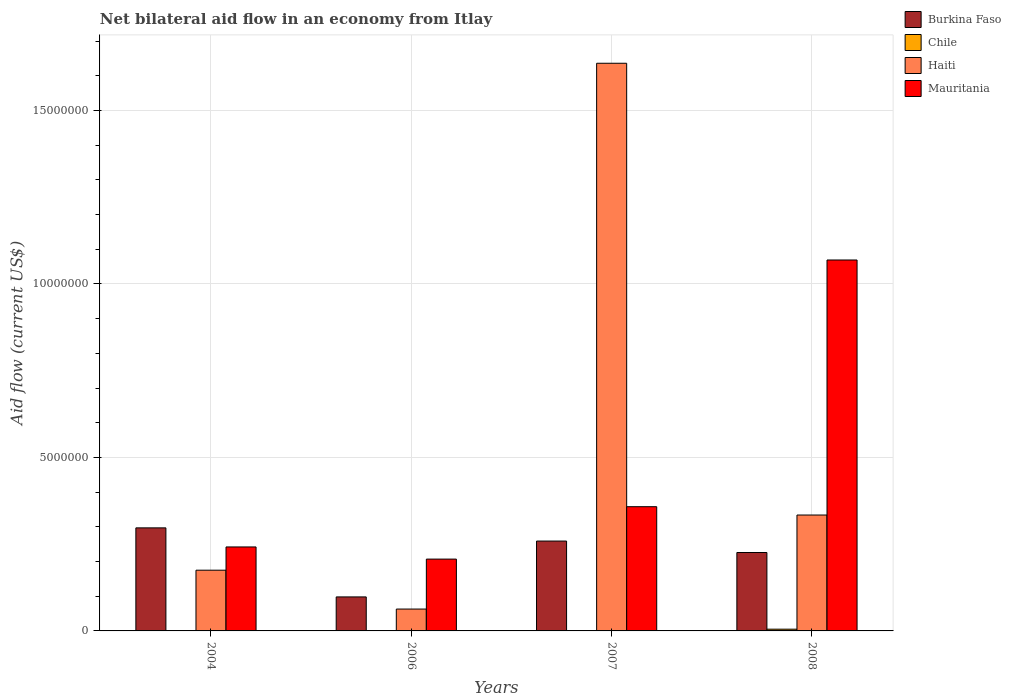How many different coloured bars are there?
Offer a terse response. 4. What is the label of the 3rd group of bars from the left?
Keep it short and to the point. 2007. What is the net bilateral aid flow in Mauritania in 2006?
Provide a short and direct response. 2.07e+06. Across all years, what is the maximum net bilateral aid flow in Haiti?
Provide a short and direct response. 1.64e+07. Across all years, what is the minimum net bilateral aid flow in Mauritania?
Give a very brief answer. 2.07e+06. What is the total net bilateral aid flow in Chile in the graph?
Offer a terse response. 5.00e+04. What is the difference between the net bilateral aid flow in Mauritania in 2006 and that in 2007?
Your answer should be compact. -1.51e+06. What is the difference between the net bilateral aid flow in Haiti in 2008 and the net bilateral aid flow in Mauritania in 2004?
Ensure brevity in your answer.  9.20e+05. What is the average net bilateral aid flow in Mauritania per year?
Give a very brief answer. 4.69e+06. In the year 2008, what is the difference between the net bilateral aid flow in Chile and net bilateral aid flow in Haiti?
Ensure brevity in your answer.  -3.29e+06. What is the ratio of the net bilateral aid flow in Burkina Faso in 2004 to that in 2006?
Offer a very short reply. 3.03. What is the difference between the highest and the second highest net bilateral aid flow in Haiti?
Offer a terse response. 1.30e+07. What is the difference between the highest and the lowest net bilateral aid flow in Mauritania?
Make the answer very short. 8.62e+06. In how many years, is the net bilateral aid flow in Haiti greater than the average net bilateral aid flow in Haiti taken over all years?
Your answer should be very brief. 1. Is it the case that in every year, the sum of the net bilateral aid flow in Haiti and net bilateral aid flow in Burkina Faso is greater than the sum of net bilateral aid flow in Chile and net bilateral aid flow in Mauritania?
Give a very brief answer. No. How many bars are there?
Provide a short and direct response. 13. What is the difference between two consecutive major ticks on the Y-axis?
Ensure brevity in your answer.  5.00e+06. Are the values on the major ticks of Y-axis written in scientific E-notation?
Provide a short and direct response. No. Does the graph contain any zero values?
Your answer should be very brief. Yes. Where does the legend appear in the graph?
Keep it short and to the point. Top right. How are the legend labels stacked?
Provide a short and direct response. Vertical. What is the title of the graph?
Provide a short and direct response. Net bilateral aid flow in an economy from Itlay. Does "Europe(developing only)" appear as one of the legend labels in the graph?
Offer a terse response. No. What is the label or title of the Y-axis?
Your answer should be very brief. Aid flow (current US$). What is the Aid flow (current US$) of Burkina Faso in 2004?
Provide a short and direct response. 2.97e+06. What is the Aid flow (current US$) in Chile in 2004?
Give a very brief answer. 0. What is the Aid flow (current US$) in Haiti in 2004?
Your answer should be very brief. 1.75e+06. What is the Aid flow (current US$) of Mauritania in 2004?
Your answer should be very brief. 2.42e+06. What is the Aid flow (current US$) in Burkina Faso in 2006?
Provide a succinct answer. 9.80e+05. What is the Aid flow (current US$) of Chile in 2006?
Make the answer very short. 0. What is the Aid flow (current US$) of Haiti in 2006?
Make the answer very short. 6.30e+05. What is the Aid flow (current US$) in Mauritania in 2006?
Provide a succinct answer. 2.07e+06. What is the Aid flow (current US$) in Burkina Faso in 2007?
Provide a succinct answer. 2.59e+06. What is the Aid flow (current US$) of Haiti in 2007?
Give a very brief answer. 1.64e+07. What is the Aid flow (current US$) of Mauritania in 2007?
Your answer should be very brief. 3.58e+06. What is the Aid flow (current US$) of Burkina Faso in 2008?
Your answer should be very brief. 2.26e+06. What is the Aid flow (current US$) in Chile in 2008?
Offer a very short reply. 5.00e+04. What is the Aid flow (current US$) of Haiti in 2008?
Offer a very short reply. 3.34e+06. What is the Aid flow (current US$) of Mauritania in 2008?
Provide a succinct answer. 1.07e+07. Across all years, what is the maximum Aid flow (current US$) of Burkina Faso?
Keep it short and to the point. 2.97e+06. Across all years, what is the maximum Aid flow (current US$) of Haiti?
Provide a short and direct response. 1.64e+07. Across all years, what is the maximum Aid flow (current US$) in Mauritania?
Keep it short and to the point. 1.07e+07. Across all years, what is the minimum Aid flow (current US$) in Burkina Faso?
Offer a very short reply. 9.80e+05. Across all years, what is the minimum Aid flow (current US$) of Chile?
Your answer should be compact. 0. Across all years, what is the minimum Aid flow (current US$) in Haiti?
Your answer should be compact. 6.30e+05. Across all years, what is the minimum Aid flow (current US$) of Mauritania?
Your response must be concise. 2.07e+06. What is the total Aid flow (current US$) of Burkina Faso in the graph?
Give a very brief answer. 8.80e+06. What is the total Aid flow (current US$) in Chile in the graph?
Give a very brief answer. 5.00e+04. What is the total Aid flow (current US$) in Haiti in the graph?
Give a very brief answer. 2.21e+07. What is the total Aid flow (current US$) in Mauritania in the graph?
Offer a very short reply. 1.88e+07. What is the difference between the Aid flow (current US$) in Burkina Faso in 2004 and that in 2006?
Your response must be concise. 1.99e+06. What is the difference between the Aid flow (current US$) in Haiti in 2004 and that in 2006?
Provide a short and direct response. 1.12e+06. What is the difference between the Aid flow (current US$) in Haiti in 2004 and that in 2007?
Your response must be concise. -1.46e+07. What is the difference between the Aid flow (current US$) in Mauritania in 2004 and that in 2007?
Keep it short and to the point. -1.16e+06. What is the difference between the Aid flow (current US$) of Burkina Faso in 2004 and that in 2008?
Offer a very short reply. 7.10e+05. What is the difference between the Aid flow (current US$) in Haiti in 2004 and that in 2008?
Make the answer very short. -1.59e+06. What is the difference between the Aid flow (current US$) in Mauritania in 2004 and that in 2008?
Keep it short and to the point. -8.27e+06. What is the difference between the Aid flow (current US$) in Burkina Faso in 2006 and that in 2007?
Make the answer very short. -1.61e+06. What is the difference between the Aid flow (current US$) in Haiti in 2006 and that in 2007?
Make the answer very short. -1.57e+07. What is the difference between the Aid flow (current US$) of Mauritania in 2006 and that in 2007?
Your response must be concise. -1.51e+06. What is the difference between the Aid flow (current US$) of Burkina Faso in 2006 and that in 2008?
Your answer should be very brief. -1.28e+06. What is the difference between the Aid flow (current US$) in Haiti in 2006 and that in 2008?
Give a very brief answer. -2.71e+06. What is the difference between the Aid flow (current US$) in Mauritania in 2006 and that in 2008?
Your answer should be very brief. -8.62e+06. What is the difference between the Aid flow (current US$) of Burkina Faso in 2007 and that in 2008?
Offer a very short reply. 3.30e+05. What is the difference between the Aid flow (current US$) of Haiti in 2007 and that in 2008?
Give a very brief answer. 1.30e+07. What is the difference between the Aid flow (current US$) in Mauritania in 2007 and that in 2008?
Your response must be concise. -7.11e+06. What is the difference between the Aid flow (current US$) in Burkina Faso in 2004 and the Aid flow (current US$) in Haiti in 2006?
Ensure brevity in your answer.  2.34e+06. What is the difference between the Aid flow (current US$) in Haiti in 2004 and the Aid flow (current US$) in Mauritania in 2006?
Give a very brief answer. -3.20e+05. What is the difference between the Aid flow (current US$) of Burkina Faso in 2004 and the Aid flow (current US$) of Haiti in 2007?
Your answer should be compact. -1.34e+07. What is the difference between the Aid flow (current US$) of Burkina Faso in 2004 and the Aid flow (current US$) of Mauritania in 2007?
Your answer should be very brief. -6.10e+05. What is the difference between the Aid flow (current US$) of Haiti in 2004 and the Aid flow (current US$) of Mauritania in 2007?
Make the answer very short. -1.83e+06. What is the difference between the Aid flow (current US$) of Burkina Faso in 2004 and the Aid flow (current US$) of Chile in 2008?
Offer a very short reply. 2.92e+06. What is the difference between the Aid flow (current US$) of Burkina Faso in 2004 and the Aid flow (current US$) of Haiti in 2008?
Keep it short and to the point. -3.70e+05. What is the difference between the Aid flow (current US$) in Burkina Faso in 2004 and the Aid flow (current US$) in Mauritania in 2008?
Your answer should be compact. -7.72e+06. What is the difference between the Aid flow (current US$) in Haiti in 2004 and the Aid flow (current US$) in Mauritania in 2008?
Offer a very short reply. -8.94e+06. What is the difference between the Aid flow (current US$) of Burkina Faso in 2006 and the Aid flow (current US$) of Haiti in 2007?
Ensure brevity in your answer.  -1.54e+07. What is the difference between the Aid flow (current US$) of Burkina Faso in 2006 and the Aid flow (current US$) of Mauritania in 2007?
Provide a short and direct response. -2.60e+06. What is the difference between the Aid flow (current US$) in Haiti in 2006 and the Aid flow (current US$) in Mauritania in 2007?
Ensure brevity in your answer.  -2.95e+06. What is the difference between the Aid flow (current US$) in Burkina Faso in 2006 and the Aid flow (current US$) in Chile in 2008?
Your answer should be compact. 9.30e+05. What is the difference between the Aid flow (current US$) of Burkina Faso in 2006 and the Aid flow (current US$) of Haiti in 2008?
Provide a succinct answer. -2.36e+06. What is the difference between the Aid flow (current US$) of Burkina Faso in 2006 and the Aid flow (current US$) of Mauritania in 2008?
Your response must be concise. -9.71e+06. What is the difference between the Aid flow (current US$) of Haiti in 2006 and the Aid flow (current US$) of Mauritania in 2008?
Your answer should be very brief. -1.01e+07. What is the difference between the Aid flow (current US$) in Burkina Faso in 2007 and the Aid flow (current US$) in Chile in 2008?
Your answer should be compact. 2.54e+06. What is the difference between the Aid flow (current US$) of Burkina Faso in 2007 and the Aid flow (current US$) of Haiti in 2008?
Your answer should be very brief. -7.50e+05. What is the difference between the Aid flow (current US$) in Burkina Faso in 2007 and the Aid flow (current US$) in Mauritania in 2008?
Offer a very short reply. -8.10e+06. What is the difference between the Aid flow (current US$) of Haiti in 2007 and the Aid flow (current US$) of Mauritania in 2008?
Your answer should be compact. 5.67e+06. What is the average Aid flow (current US$) in Burkina Faso per year?
Your answer should be very brief. 2.20e+06. What is the average Aid flow (current US$) of Chile per year?
Your answer should be very brief. 1.25e+04. What is the average Aid flow (current US$) in Haiti per year?
Your answer should be very brief. 5.52e+06. What is the average Aid flow (current US$) in Mauritania per year?
Provide a succinct answer. 4.69e+06. In the year 2004, what is the difference between the Aid flow (current US$) in Burkina Faso and Aid flow (current US$) in Haiti?
Provide a short and direct response. 1.22e+06. In the year 2004, what is the difference between the Aid flow (current US$) of Burkina Faso and Aid flow (current US$) of Mauritania?
Provide a succinct answer. 5.50e+05. In the year 2004, what is the difference between the Aid flow (current US$) in Haiti and Aid flow (current US$) in Mauritania?
Give a very brief answer. -6.70e+05. In the year 2006, what is the difference between the Aid flow (current US$) in Burkina Faso and Aid flow (current US$) in Haiti?
Your answer should be very brief. 3.50e+05. In the year 2006, what is the difference between the Aid flow (current US$) of Burkina Faso and Aid flow (current US$) of Mauritania?
Keep it short and to the point. -1.09e+06. In the year 2006, what is the difference between the Aid flow (current US$) of Haiti and Aid flow (current US$) of Mauritania?
Ensure brevity in your answer.  -1.44e+06. In the year 2007, what is the difference between the Aid flow (current US$) in Burkina Faso and Aid flow (current US$) in Haiti?
Provide a short and direct response. -1.38e+07. In the year 2007, what is the difference between the Aid flow (current US$) of Burkina Faso and Aid flow (current US$) of Mauritania?
Give a very brief answer. -9.90e+05. In the year 2007, what is the difference between the Aid flow (current US$) in Haiti and Aid flow (current US$) in Mauritania?
Provide a succinct answer. 1.28e+07. In the year 2008, what is the difference between the Aid flow (current US$) in Burkina Faso and Aid flow (current US$) in Chile?
Provide a succinct answer. 2.21e+06. In the year 2008, what is the difference between the Aid flow (current US$) of Burkina Faso and Aid flow (current US$) of Haiti?
Offer a very short reply. -1.08e+06. In the year 2008, what is the difference between the Aid flow (current US$) in Burkina Faso and Aid flow (current US$) in Mauritania?
Provide a short and direct response. -8.43e+06. In the year 2008, what is the difference between the Aid flow (current US$) in Chile and Aid flow (current US$) in Haiti?
Keep it short and to the point. -3.29e+06. In the year 2008, what is the difference between the Aid flow (current US$) of Chile and Aid flow (current US$) of Mauritania?
Provide a short and direct response. -1.06e+07. In the year 2008, what is the difference between the Aid flow (current US$) of Haiti and Aid flow (current US$) of Mauritania?
Provide a succinct answer. -7.35e+06. What is the ratio of the Aid flow (current US$) of Burkina Faso in 2004 to that in 2006?
Make the answer very short. 3.03. What is the ratio of the Aid flow (current US$) in Haiti in 2004 to that in 2006?
Your answer should be very brief. 2.78. What is the ratio of the Aid flow (current US$) in Mauritania in 2004 to that in 2006?
Give a very brief answer. 1.17. What is the ratio of the Aid flow (current US$) of Burkina Faso in 2004 to that in 2007?
Your answer should be compact. 1.15. What is the ratio of the Aid flow (current US$) in Haiti in 2004 to that in 2007?
Your answer should be very brief. 0.11. What is the ratio of the Aid flow (current US$) of Mauritania in 2004 to that in 2007?
Provide a succinct answer. 0.68. What is the ratio of the Aid flow (current US$) of Burkina Faso in 2004 to that in 2008?
Give a very brief answer. 1.31. What is the ratio of the Aid flow (current US$) in Haiti in 2004 to that in 2008?
Give a very brief answer. 0.52. What is the ratio of the Aid flow (current US$) of Mauritania in 2004 to that in 2008?
Offer a terse response. 0.23. What is the ratio of the Aid flow (current US$) of Burkina Faso in 2006 to that in 2007?
Your answer should be very brief. 0.38. What is the ratio of the Aid flow (current US$) of Haiti in 2006 to that in 2007?
Your response must be concise. 0.04. What is the ratio of the Aid flow (current US$) of Mauritania in 2006 to that in 2007?
Keep it short and to the point. 0.58. What is the ratio of the Aid flow (current US$) in Burkina Faso in 2006 to that in 2008?
Your answer should be compact. 0.43. What is the ratio of the Aid flow (current US$) in Haiti in 2006 to that in 2008?
Offer a terse response. 0.19. What is the ratio of the Aid flow (current US$) of Mauritania in 2006 to that in 2008?
Offer a terse response. 0.19. What is the ratio of the Aid flow (current US$) in Burkina Faso in 2007 to that in 2008?
Your answer should be compact. 1.15. What is the ratio of the Aid flow (current US$) in Haiti in 2007 to that in 2008?
Provide a short and direct response. 4.9. What is the ratio of the Aid flow (current US$) in Mauritania in 2007 to that in 2008?
Your response must be concise. 0.33. What is the difference between the highest and the second highest Aid flow (current US$) in Burkina Faso?
Offer a very short reply. 3.80e+05. What is the difference between the highest and the second highest Aid flow (current US$) in Haiti?
Your answer should be compact. 1.30e+07. What is the difference between the highest and the second highest Aid flow (current US$) in Mauritania?
Keep it short and to the point. 7.11e+06. What is the difference between the highest and the lowest Aid flow (current US$) in Burkina Faso?
Give a very brief answer. 1.99e+06. What is the difference between the highest and the lowest Aid flow (current US$) in Chile?
Make the answer very short. 5.00e+04. What is the difference between the highest and the lowest Aid flow (current US$) of Haiti?
Keep it short and to the point. 1.57e+07. What is the difference between the highest and the lowest Aid flow (current US$) of Mauritania?
Keep it short and to the point. 8.62e+06. 